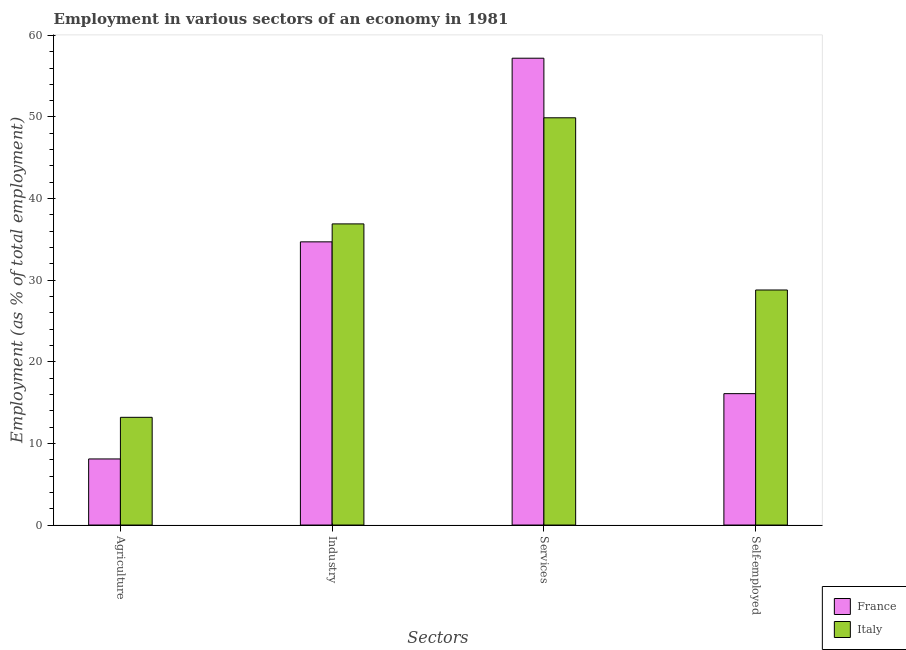How many groups of bars are there?
Ensure brevity in your answer.  4. Are the number of bars per tick equal to the number of legend labels?
Offer a terse response. Yes. Are the number of bars on each tick of the X-axis equal?
Offer a very short reply. Yes. What is the label of the 1st group of bars from the left?
Give a very brief answer. Agriculture. What is the percentage of workers in industry in France?
Provide a succinct answer. 34.7. Across all countries, what is the maximum percentage of self employed workers?
Offer a terse response. 28.8. Across all countries, what is the minimum percentage of workers in services?
Your answer should be very brief. 49.9. In which country was the percentage of self employed workers minimum?
Provide a short and direct response. France. What is the total percentage of workers in agriculture in the graph?
Offer a terse response. 21.3. What is the difference between the percentage of workers in agriculture in Italy and that in France?
Provide a succinct answer. 5.1. What is the difference between the percentage of workers in agriculture in Italy and the percentage of workers in services in France?
Your answer should be very brief. -44. What is the average percentage of workers in services per country?
Provide a succinct answer. 53.55. What is the difference between the percentage of workers in industry and percentage of workers in agriculture in Italy?
Ensure brevity in your answer.  23.7. In how many countries, is the percentage of workers in industry greater than 20 %?
Provide a succinct answer. 2. What is the ratio of the percentage of workers in services in Italy to that in France?
Keep it short and to the point. 0.87. Is the difference between the percentage of workers in industry in France and Italy greater than the difference between the percentage of self employed workers in France and Italy?
Your answer should be compact. Yes. What is the difference between the highest and the second highest percentage of workers in services?
Give a very brief answer. 7.3. What is the difference between the highest and the lowest percentage of workers in agriculture?
Offer a very short reply. 5.1. What does the 2nd bar from the left in Self-employed represents?
Give a very brief answer. Italy. What does the 1st bar from the right in Industry represents?
Make the answer very short. Italy. Is it the case that in every country, the sum of the percentage of workers in agriculture and percentage of workers in industry is greater than the percentage of workers in services?
Ensure brevity in your answer.  No. What is the difference between two consecutive major ticks on the Y-axis?
Ensure brevity in your answer.  10. Are the values on the major ticks of Y-axis written in scientific E-notation?
Make the answer very short. No. Does the graph contain grids?
Offer a terse response. No. Where does the legend appear in the graph?
Offer a terse response. Bottom right. What is the title of the graph?
Your response must be concise. Employment in various sectors of an economy in 1981. Does "Uganda" appear as one of the legend labels in the graph?
Your response must be concise. No. What is the label or title of the X-axis?
Provide a short and direct response. Sectors. What is the label or title of the Y-axis?
Provide a short and direct response. Employment (as % of total employment). What is the Employment (as % of total employment) in France in Agriculture?
Provide a short and direct response. 8.1. What is the Employment (as % of total employment) in Italy in Agriculture?
Keep it short and to the point. 13.2. What is the Employment (as % of total employment) of France in Industry?
Ensure brevity in your answer.  34.7. What is the Employment (as % of total employment) in Italy in Industry?
Ensure brevity in your answer.  36.9. What is the Employment (as % of total employment) in France in Services?
Your response must be concise. 57.2. What is the Employment (as % of total employment) in Italy in Services?
Your response must be concise. 49.9. What is the Employment (as % of total employment) of France in Self-employed?
Ensure brevity in your answer.  16.1. What is the Employment (as % of total employment) of Italy in Self-employed?
Provide a succinct answer. 28.8. Across all Sectors, what is the maximum Employment (as % of total employment) of France?
Offer a very short reply. 57.2. Across all Sectors, what is the maximum Employment (as % of total employment) of Italy?
Give a very brief answer. 49.9. Across all Sectors, what is the minimum Employment (as % of total employment) in France?
Offer a very short reply. 8.1. Across all Sectors, what is the minimum Employment (as % of total employment) of Italy?
Your response must be concise. 13.2. What is the total Employment (as % of total employment) of France in the graph?
Make the answer very short. 116.1. What is the total Employment (as % of total employment) in Italy in the graph?
Your response must be concise. 128.8. What is the difference between the Employment (as % of total employment) in France in Agriculture and that in Industry?
Provide a short and direct response. -26.6. What is the difference between the Employment (as % of total employment) in Italy in Agriculture and that in Industry?
Your answer should be compact. -23.7. What is the difference between the Employment (as % of total employment) in France in Agriculture and that in Services?
Provide a short and direct response. -49.1. What is the difference between the Employment (as % of total employment) of Italy in Agriculture and that in Services?
Offer a terse response. -36.7. What is the difference between the Employment (as % of total employment) of Italy in Agriculture and that in Self-employed?
Give a very brief answer. -15.6. What is the difference between the Employment (as % of total employment) in France in Industry and that in Services?
Offer a very short reply. -22.5. What is the difference between the Employment (as % of total employment) of France in Services and that in Self-employed?
Provide a short and direct response. 41.1. What is the difference between the Employment (as % of total employment) in Italy in Services and that in Self-employed?
Offer a very short reply. 21.1. What is the difference between the Employment (as % of total employment) of France in Agriculture and the Employment (as % of total employment) of Italy in Industry?
Keep it short and to the point. -28.8. What is the difference between the Employment (as % of total employment) in France in Agriculture and the Employment (as % of total employment) in Italy in Services?
Your answer should be compact. -41.8. What is the difference between the Employment (as % of total employment) in France in Agriculture and the Employment (as % of total employment) in Italy in Self-employed?
Keep it short and to the point. -20.7. What is the difference between the Employment (as % of total employment) in France in Industry and the Employment (as % of total employment) in Italy in Services?
Give a very brief answer. -15.2. What is the difference between the Employment (as % of total employment) of France in Industry and the Employment (as % of total employment) of Italy in Self-employed?
Offer a very short reply. 5.9. What is the difference between the Employment (as % of total employment) in France in Services and the Employment (as % of total employment) in Italy in Self-employed?
Your answer should be very brief. 28.4. What is the average Employment (as % of total employment) of France per Sectors?
Give a very brief answer. 29.02. What is the average Employment (as % of total employment) in Italy per Sectors?
Offer a terse response. 32.2. What is the difference between the Employment (as % of total employment) in France and Employment (as % of total employment) in Italy in Industry?
Offer a terse response. -2.2. What is the difference between the Employment (as % of total employment) of France and Employment (as % of total employment) of Italy in Self-employed?
Your response must be concise. -12.7. What is the ratio of the Employment (as % of total employment) of France in Agriculture to that in Industry?
Provide a short and direct response. 0.23. What is the ratio of the Employment (as % of total employment) of Italy in Agriculture to that in Industry?
Give a very brief answer. 0.36. What is the ratio of the Employment (as % of total employment) of France in Agriculture to that in Services?
Offer a very short reply. 0.14. What is the ratio of the Employment (as % of total employment) of Italy in Agriculture to that in Services?
Your response must be concise. 0.26. What is the ratio of the Employment (as % of total employment) of France in Agriculture to that in Self-employed?
Provide a short and direct response. 0.5. What is the ratio of the Employment (as % of total employment) in Italy in Agriculture to that in Self-employed?
Provide a short and direct response. 0.46. What is the ratio of the Employment (as % of total employment) of France in Industry to that in Services?
Your answer should be very brief. 0.61. What is the ratio of the Employment (as % of total employment) in Italy in Industry to that in Services?
Keep it short and to the point. 0.74. What is the ratio of the Employment (as % of total employment) of France in Industry to that in Self-employed?
Your answer should be compact. 2.16. What is the ratio of the Employment (as % of total employment) in Italy in Industry to that in Self-employed?
Your answer should be compact. 1.28. What is the ratio of the Employment (as % of total employment) in France in Services to that in Self-employed?
Provide a succinct answer. 3.55. What is the ratio of the Employment (as % of total employment) in Italy in Services to that in Self-employed?
Offer a very short reply. 1.73. What is the difference between the highest and the lowest Employment (as % of total employment) of France?
Offer a very short reply. 49.1. What is the difference between the highest and the lowest Employment (as % of total employment) of Italy?
Ensure brevity in your answer.  36.7. 